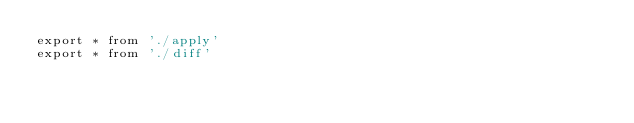<code> <loc_0><loc_0><loc_500><loc_500><_TypeScript_>export * from './apply'
export * from './diff'
</code> 